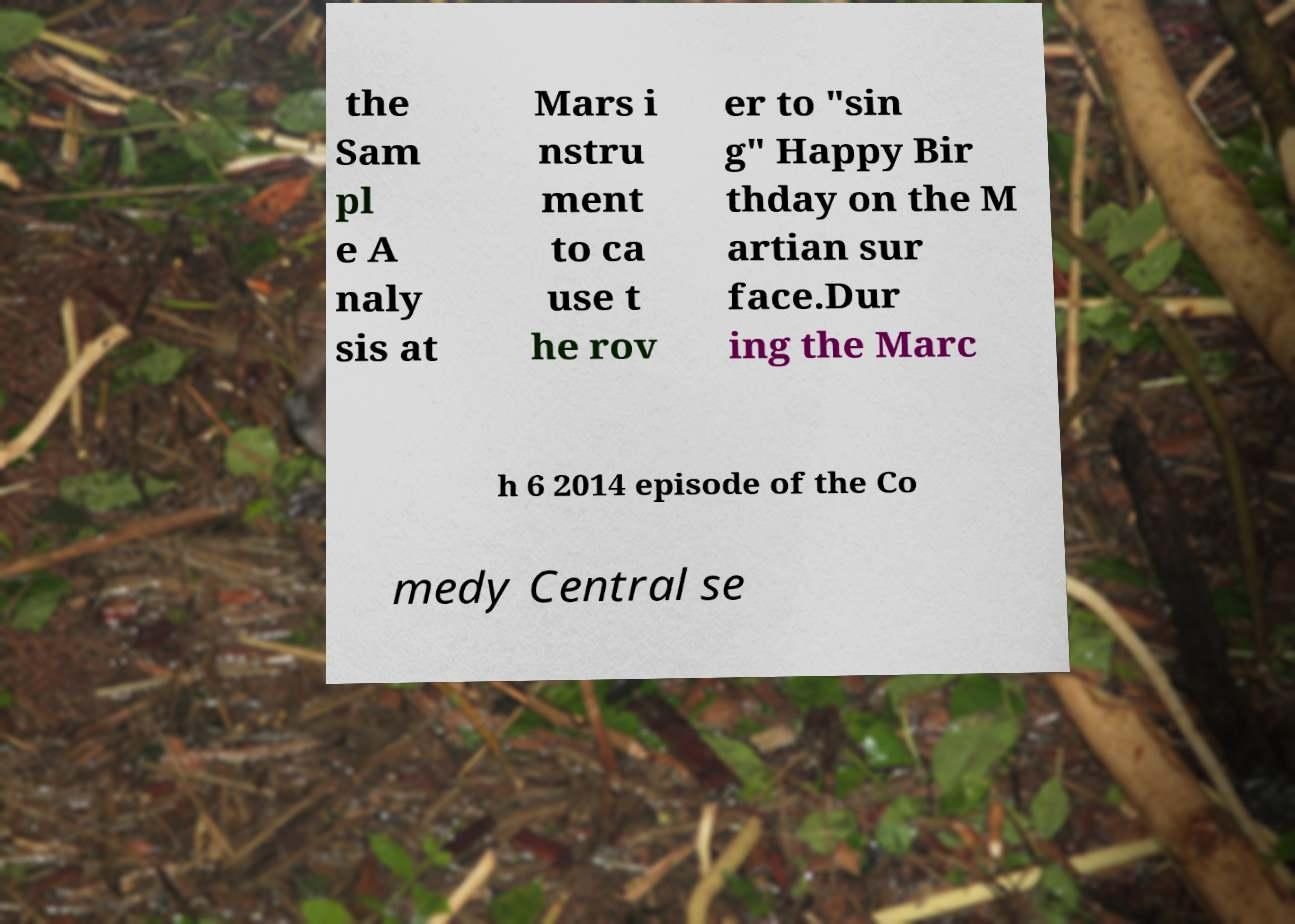Can you accurately transcribe the text from the provided image for me? the Sam pl e A naly sis at Mars i nstru ment to ca use t he rov er to "sin g" Happy Bir thday on the M artian sur face.Dur ing the Marc h 6 2014 episode of the Co medy Central se 